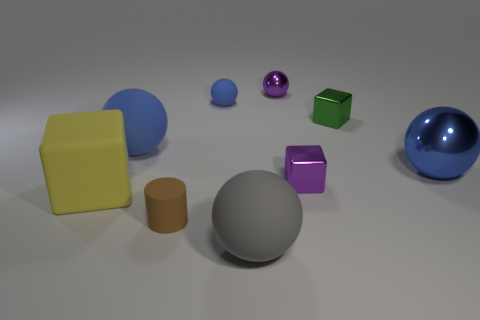How many blue balls must be subtracted to get 1 blue balls? 2 Subtract all brown cubes. How many blue spheres are left? 3 Subtract 1 balls. How many balls are left? 4 Subtract all green balls. Subtract all purple cylinders. How many balls are left? 5 Add 1 tiny brown things. How many objects exist? 10 Subtract all spheres. How many objects are left? 4 Add 3 small blue balls. How many small blue balls exist? 4 Subtract 0 red blocks. How many objects are left? 9 Subtract all big brown balls. Subtract all large blue matte balls. How many objects are left? 8 Add 7 tiny brown cylinders. How many tiny brown cylinders are left? 8 